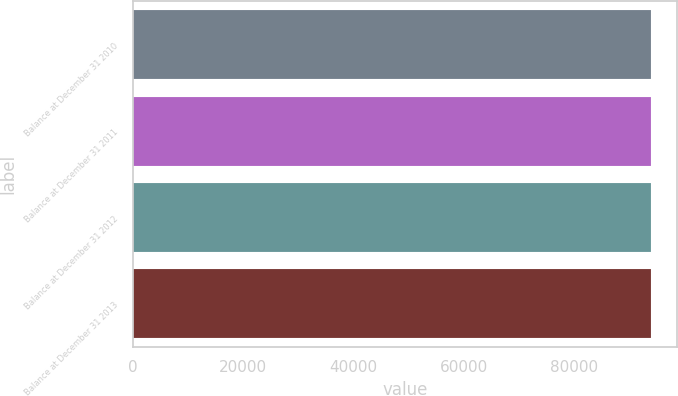<chart> <loc_0><loc_0><loc_500><loc_500><bar_chart><fcel>Balance at December 31 2010<fcel>Balance at December 31 2011<fcel>Balance at December 31 2012<fcel>Balance at December 31 2013<nl><fcel>94000<fcel>94000.1<fcel>94000.2<fcel>94000.3<nl></chart> 